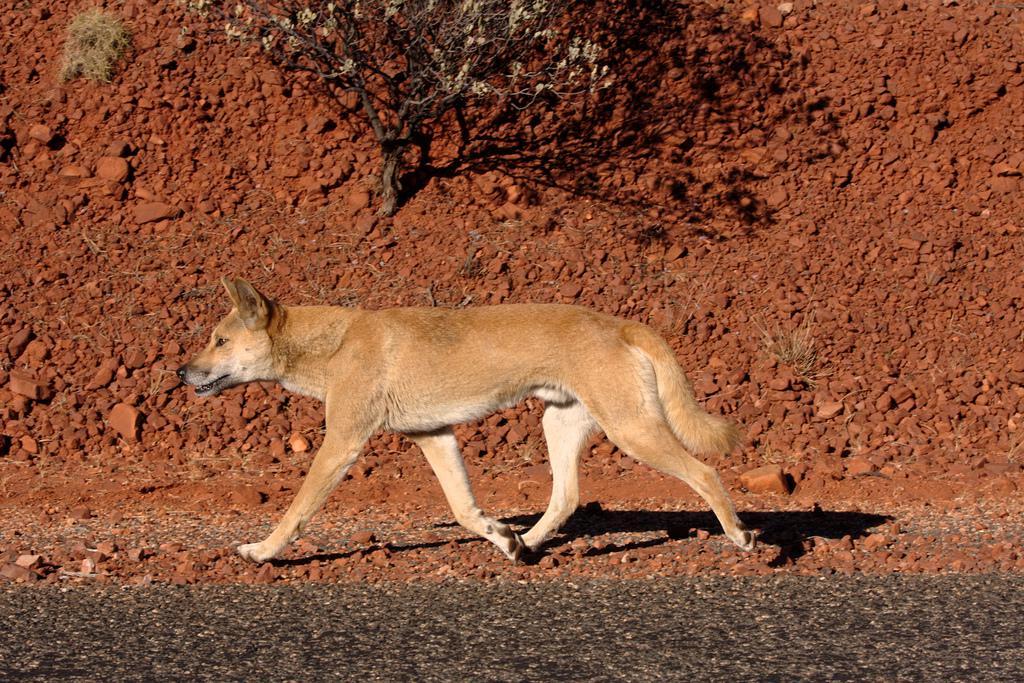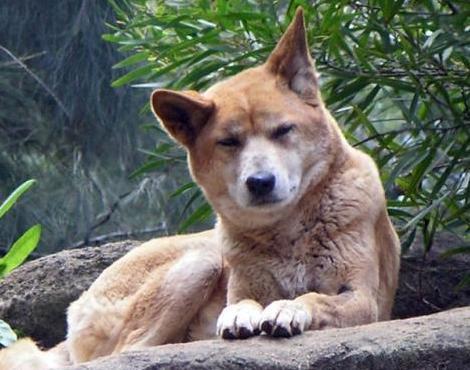The first image is the image on the left, the second image is the image on the right. Analyze the images presented: Is the assertion "All golden colored dogs are standing up in the grass (not laying down.)" valid? Answer yes or no. No. The first image is the image on the left, the second image is the image on the right. Analyze the images presented: Is the assertion "One image contains a reclining dingo and the other contains a dingo that is walking with body in profile." valid? Answer yes or no. Yes. 